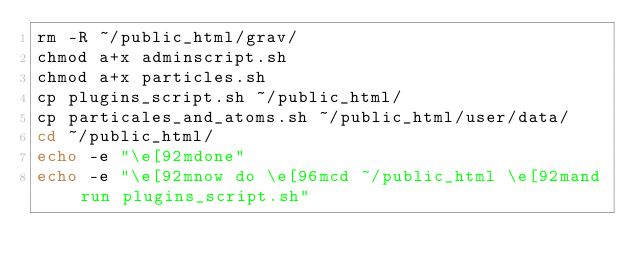Convert code to text. <code><loc_0><loc_0><loc_500><loc_500><_Bash_>rm -R ~/public_html/grav/
chmod a+x adminscript.sh
chmod a+x particles.sh
cp plugins_script.sh ~/public_html/
cp particales_and_atoms.sh ~/public_html/user/data/
cd ~/public_html/
echo -e "\e[92mdone"
echo -e "\e[92mnow do \e[96mcd ~/public_html \e[92mand run plugins_script.sh"
</code> 